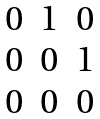<formula> <loc_0><loc_0><loc_500><loc_500>\begin{matrix} 0 & 1 & 0 \\ 0 & 0 & 1 \\ 0 & 0 & 0 \\ \end{matrix}</formula> 